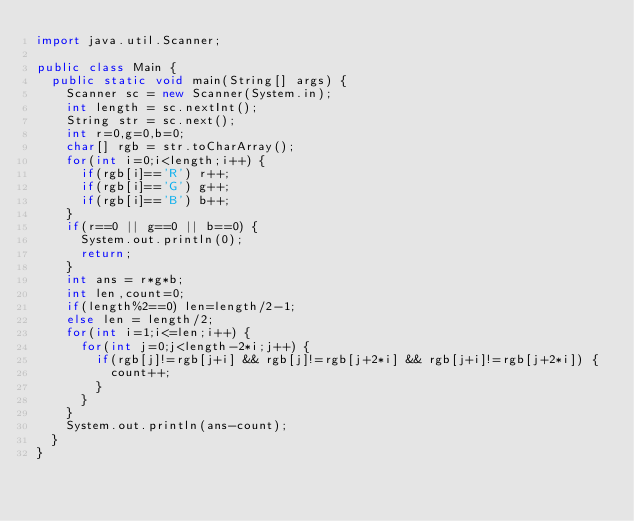<code> <loc_0><loc_0><loc_500><loc_500><_Java_>import java.util.Scanner;

public class Main {
	public static void main(String[] args) {
		Scanner sc = new Scanner(System.in);
		int length = sc.nextInt();
		String str = sc.next();
		int r=0,g=0,b=0;
		char[] rgb = str.toCharArray();
		for(int i=0;i<length;i++) {
			if(rgb[i]=='R') r++;
			if(rgb[i]=='G') g++;
			if(rgb[i]=='B') b++;
		}
		if(r==0 || g==0 || b==0) {
			System.out.println(0);
			return;
		}
		int ans = r*g*b;
		int len,count=0;
		if(length%2==0) len=length/2-1;
		else len = length/2;
		for(int i=1;i<=len;i++) {
			for(int j=0;j<length-2*i;j++) {
				if(rgb[j]!=rgb[j+i] && rgb[j]!=rgb[j+2*i] && rgb[j+i]!=rgb[j+2*i]) {
					count++;
				}
			}
		}
		System.out.println(ans-count);
	}
}</code> 